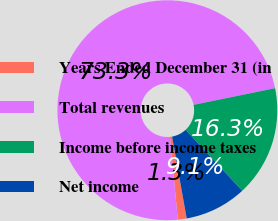Convert chart to OTSL. <chart><loc_0><loc_0><loc_500><loc_500><pie_chart><fcel>Years Ended December 31 (in<fcel>Total revenues<fcel>Income before income taxes<fcel>Net income<nl><fcel>1.3%<fcel>73.31%<fcel>16.3%<fcel>9.1%<nl></chart> 